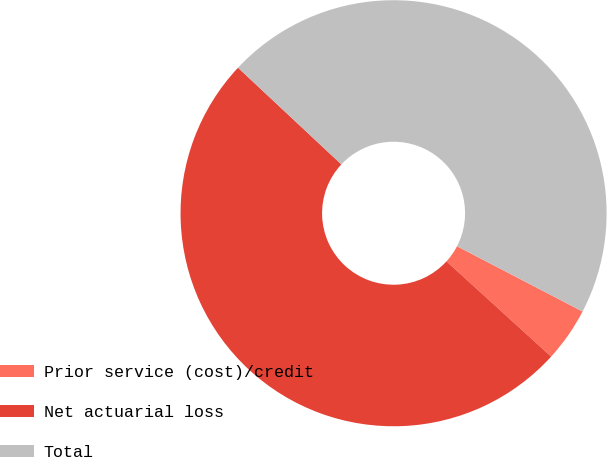Convert chart to OTSL. <chart><loc_0><loc_0><loc_500><loc_500><pie_chart><fcel>Prior service (cost)/credit<fcel>Net actuarial loss<fcel>Total<nl><fcel>4.12%<fcel>50.22%<fcel>45.66%<nl></chart> 